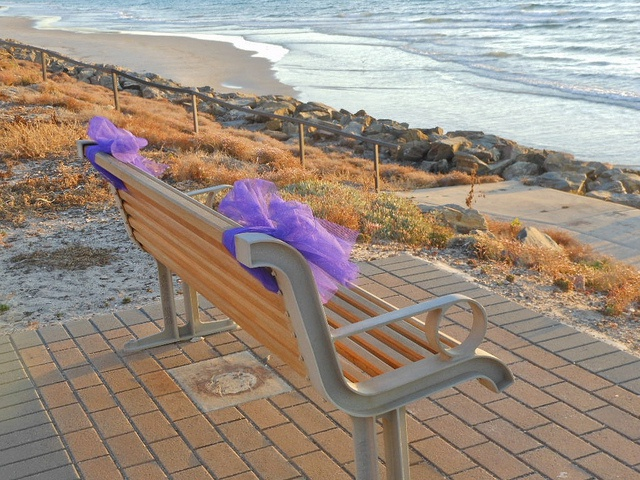Describe the objects in this image and their specific colors. I can see a bench in lightblue, gray, and darkgray tones in this image. 